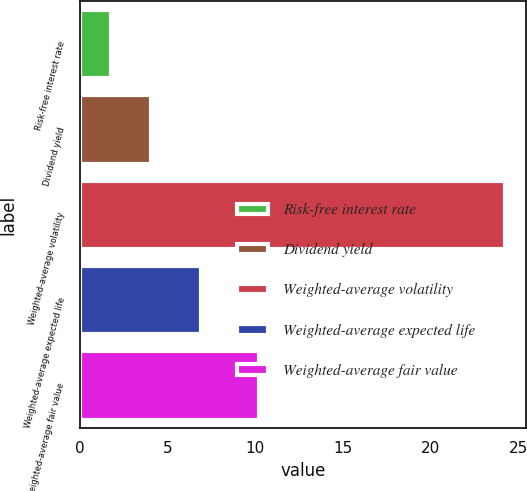Convert chart to OTSL. <chart><loc_0><loc_0><loc_500><loc_500><bar_chart><fcel>Risk-free interest rate<fcel>Dividend yield<fcel>Weighted-average volatility<fcel>Weighted-average expected life<fcel>Weighted-average fair value<nl><fcel>1.8<fcel>4.04<fcel>24.2<fcel>6.9<fcel>10.21<nl></chart> 